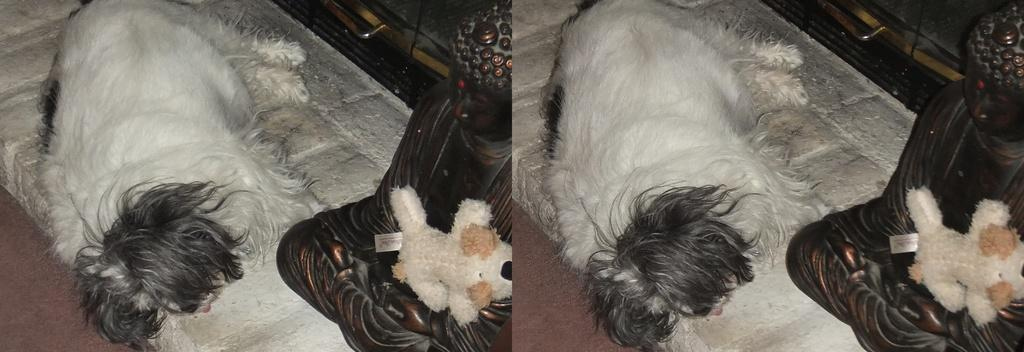What animal can be seen in the image? There is a dog lying on a surface in the image. What else is present in the image besides the dog? There is a toy on an object in the image. Can you describe the surroundings in the image? A path is visible in the image. What type of operation is being performed on the glass in the image? There is no glass present in the image, and therefore no operation is being performed on it. 